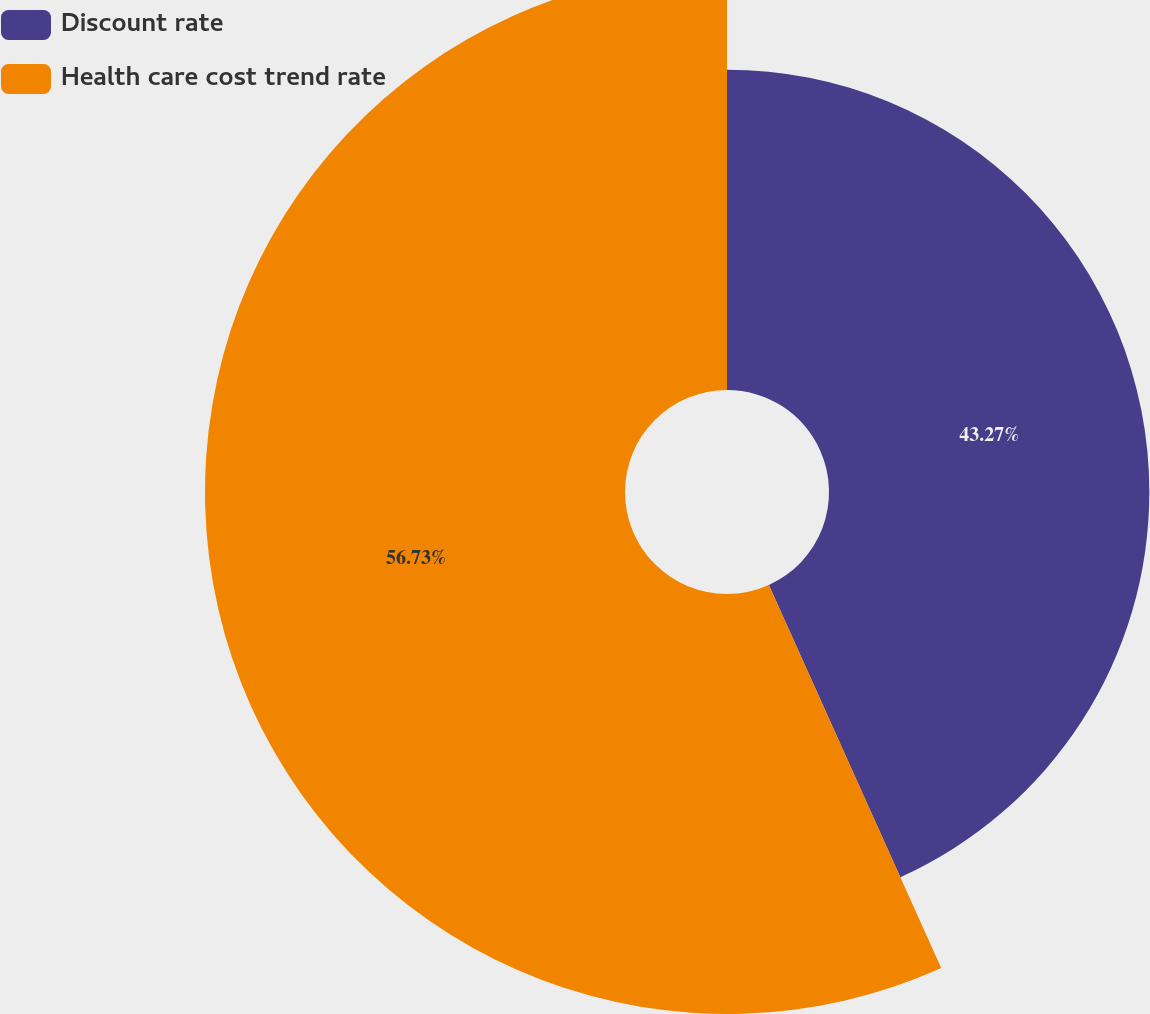<chart> <loc_0><loc_0><loc_500><loc_500><pie_chart><fcel>Discount rate<fcel>Health care cost trend rate<nl><fcel>43.27%<fcel>56.73%<nl></chart> 